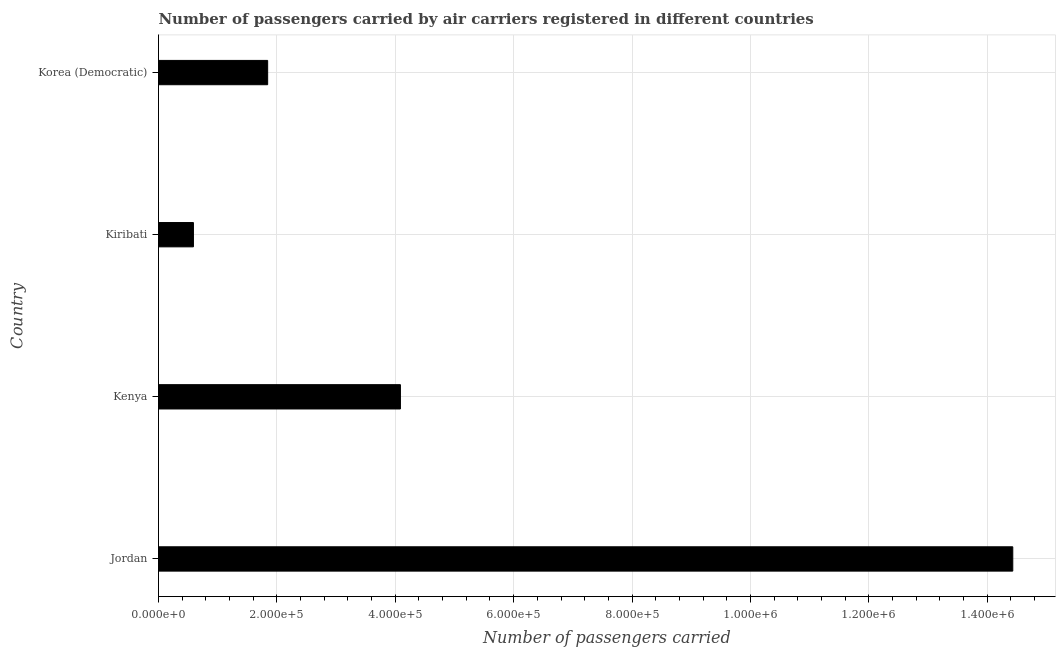Does the graph contain any zero values?
Make the answer very short. No. What is the title of the graph?
Provide a succinct answer. Number of passengers carried by air carriers registered in different countries. What is the label or title of the X-axis?
Offer a very short reply. Number of passengers carried. What is the label or title of the Y-axis?
Offer a very short reply. Country. What is the number of passengers carried in Kenya?
Your answer should be compact. 4.09e+05. Across all countries, what is the maximum number of passengers carried?
Offer a terse response. 1.44e+06. Across all countries, what is the minimum number of passengers carried?
Your answer should be compact. 5.90e+04. In which country was the number of passengers carried maximum?
Your answer should be very brief. Jordan. In which country was the number of passengers carried minimum?
Offer a very short reply. Kiribati. What is the sum of the number of passengers carried?
Your answer should be very brief. 2.10e+06. What is the difference between the number of passengers carried in Jordan and Kiribati?
Your answer should be compact. 1.38e+06. What is the average number of passengers carried per country?
Keep it short and to the point. 5.24e+05. What is the median number of passengers carried?
Your answer should be very brief. 2.97e+05. In how many countries, is the number of passengers carried greater than 240000 ?
Your answer should be very brief. 2. What is the ratio of the number of passengers carried in Jordan to that in Korea (Democratic)?
Offer a very short reply. 7.83. What is the difference between the highest and the second highest number of passengers carried?
Offer a very short reply. 1.03e+06. What is the difference between the highest and the lowest number of passengers carried?
Your response must be concise. 1.38e+06. In how many countries, is the number of passengers carried greater than the average number of passengers carried taken over all countries?
Provide a succinct answer. 1. How many countries are there in the graph?
Keep it short and to the point. 4. What is the difference between two consecutive major ticks on the X-axis?
Your answer should be very brief. 2.00e+05. Are the values on the major ticks of X-axis written in scientific E-notation?
Your answer should be very brief. Yes. What is the Number of passengers carried in Jordan?
Offer a very short reply. 1.44e+06. What is the Number of passengers carried in Kenya?
Provide a succinct answer. 4.09e+05. What is the Number of passengers carried in Kiribati?
Your answer should be compact. 5.90e+04. What is the Number of passengers carried of Korea (Democratic)?
Offer a terse response. 1.84e+05. What is the difference between the Number of passengers carried in Jordan and Kenya?
Offer a very short reply. 1.03e+06. What is the difference between the Number of passengers carried in Jordan and Kiribati?
Provide a short and direct response. 1.38e+06. What is the difference between the Number of passengers carried in Jordan and Korea (Democratic)?
Ensure brevity in your answer.  1.26e+06. What is the difference between the Number of passengers carried in Kenya and Kiribati?
Your answer should be very brief. 3.50e+05. What is the difference between the Number of passengers carried in Kenya and Korea (Democratic)?
Make the answer very short. 2.24e+05. What is the difference between the Number of passengers carried in Kiribati and Korea (Democratic)?
Keep it short and to the point. -1.25e+05. What is the ratio of the Number of passengers carried in Jordan to that in Kenya?
Your answer should be compact. 3.53. What is the ratio of the Number of passengers carried in Jordan to that in Kiribati?
Provide a short and direct response. 24.46. What is the ratio of the Number of passengers carried in Jordan to that in Korea (Democratic)?
Your response must be concise. 7.83. What is the ratio of the Number of passengers carried in Kenya to that in Kiribati?
Ensure brevity in your answer.  6.93. What is the ratio of the Number of passengers carried in Kenya to that in Korea (Democratic)?
Make the answer very short. 2.22. What is the ratio of the Number of passengers carried in Kiribati to that in Korea (Democratic)?
Keep it short and to the point. 0.32. 